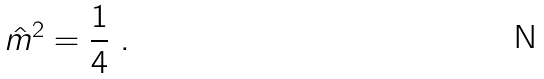Convert formula to latex. <formula><loc_0><loc_0><loc_500><loc_500>\hat { m } ^ { 2 } = \frac { 1 } { 4 } \ .</formula> 